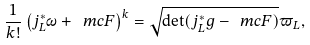Convert formula to latex. <formula><loc_0><loc_0><loc_500><loc_500>\frac { 1 } { k ! } \left ( j _ { L } ^ { * } \omega + \ m c { F } \right ) ^ { k } = \sqrt { \det ( j _ { L } ^ { * } g - \ m c { F } ) } \varpi _ { L } ,</formula> 